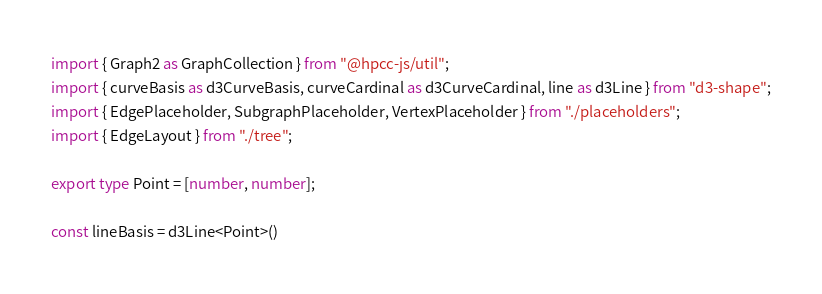<code> <loc_0><loc_0><loc_500><loc_500><_TypeScript_>import { Graph2 as GraphCollection } from "@hpcc-js/util";
import { curveBasis as d3CurveBasis, curveCardinal as d3CurveCardinal, line as d3Line } from "d3-shape";
import { EdgePlaceholder, SubgraphPlaceholder, VertexPlaceholder } from "./placeholders";
import { EdgeLayout } from "./tree";

export type Point = [number, number];

const lineBasis = d3Line<Point>()</code> 